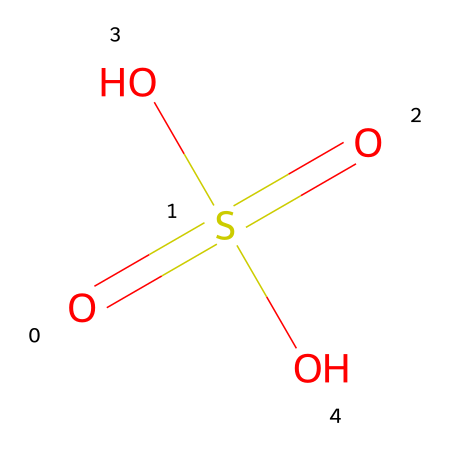What is the name of this chemical? The SMILES representation "O=S(=O)(O)O" corresponds to sulfuric acid, which is a well-known industrial chemical.
Answer: sulfuric acid How many oxygen atoms are present in this molecule? By inspecting the structure in the SMILES notation, there are four oxygen atoms in total: three from the hydroxyl groups (O) and one as part of the sulfate group (S(=O)(=O)).
Answer: four What is the central atom of this chemical? Analyzing the structure, the central atom is sulfur (S), as it is connected to multiple oxygen atoms and holds the overall chemical structure together.
Answer: sulfur What type of acid is represented by this molecule? The structure shows that it contains a sulfate group (OSO), which categorizes it as a strong acid commonly used in industrial processes.
Answer: strong acid How many double bonds are present in this molecule? In the given SMILES representation, there are two double bonds between the sulfur and oxygen atoms within the sulfate group.
Answer: two What is the typical pH range of this acid in solution? Sulfuric acid is known to create a highly acidic solution typically ranging from pH 0 to 2, depending on its concentration.
Answer: 0 to 2 What industrial processes commonly use this acid? This acid is primarily used in processes such as battery manufacturing, fertilizer production, and chemical synthesis, highlighting its importance in various sectors.
Answer: battery manufacturing 